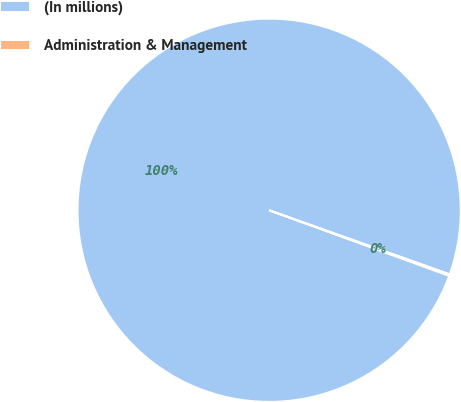Convert chart. <chart><loc_0><loc_0><loc_500><loc_500><pie_chart><fcel>(In millions)<fcel>Administration & Management<nl><fcel>99.87%<fcel>0.13%<nl></chart> 